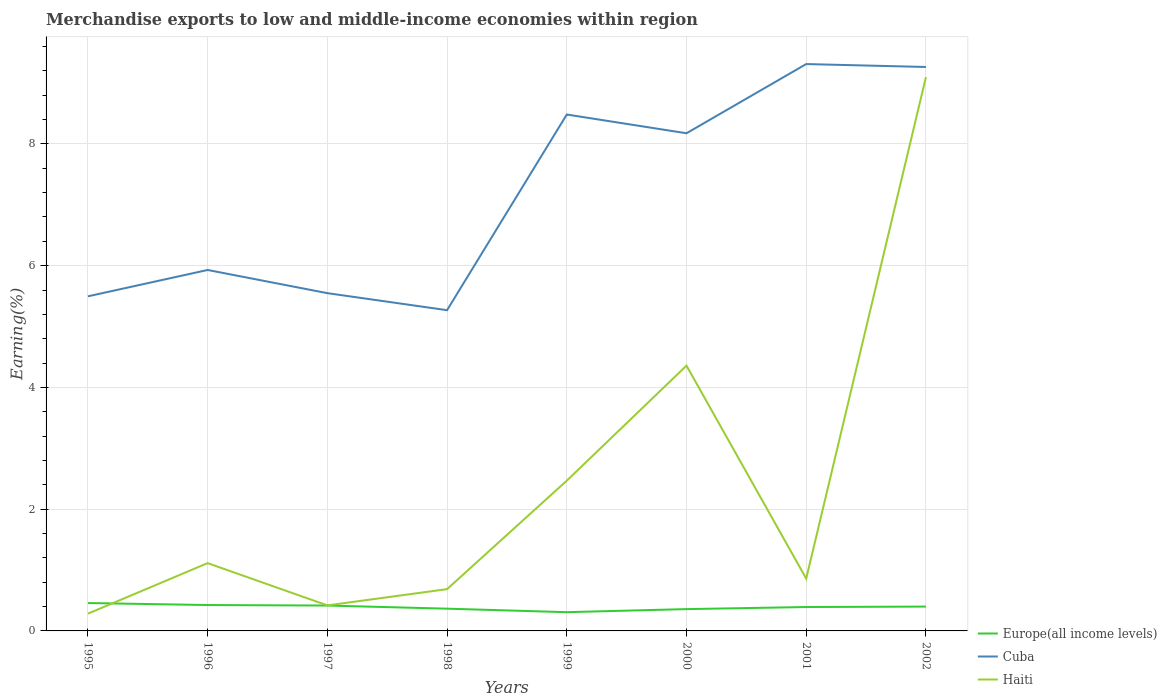How many different coloured lines are there?
Provide a succinct answer. 3. Does the line corresponding to Haiti intersect with the line corresponding to Cuba?
Ensure brevity in your answer.  No. Across all years, what is the maximum percentage of amount earned from merchandise exports in Europe(all income levels)?
Provide a short and direct response. 0.31. In which year was the percentage of amount earned from merchandise exports in Haiti maximum?
Your answer should be very brief. 1995. What is the total percentage of amount earned from merchandise exports in Cuba in the graph?
Provide a short and direct response. -0.43. What is the difference between the highest and the second highest percentage of amount earned from merchandise exports in Cuba?
Keep it short and to the point. 4.04. How many years are there in the graph?
Provide a succinct answer. 8. What is the difference between two consecutive major ticks on the Y-axis?
Make the answer very short. 2. Where does the legend appear in the graph?
Keep it short and to the point. Bottom right. What is the title of the graph?
Offer a terse response. Merchandise exports to low and middle-income economies within region. What is the label or title of the X-axis?
Provide a short and direct response. Years. What is the label or title of the Y-axis?
Give a very brief answer. Earning(%). What is the Earning(%) of Europe(all income levels) in 1995?
Ensure brevity in your answer.  0.46. What is the Earning(%) in Cuba in 1995?
Give a very brief answer. 5.5. What is the Earning(%) in Haiti in 1995?
Your answer should be very brief. 0.28. What is the Earning(%) in Europe(all income levels) in 1996?
Ensure brevity in your answer.  0.43. What is the Earning(%) of Cuba in 1996?
Your answer should be compact. 5.93. What is the Earning(%) in Haiti in 1996?
Your answer should be compact. 1.11. What is the Earning(%) in Europe(all income levels) in 1997?
Give a very brief answer. 0.42. What is the Earning(%) of Cuba in 1997?
Your answer should be very brief. 5.55. What is the Earning(%) of Haiti in 1997?
Give a very brief answer. 0.42. What is the Earning(%) in Europe(all income levels) in 1998?
Your answer should be compact. 0.37. What is the Earning(%) in Cuba in 1998?
Ensure brevity in your answer.  5.27. What is the Earning(%) in Haiti in 1998?
Keep it short and to the point. 0.69. What is the Earning(%) in Europe(all income levels) in 1999?
Ensure brevity in your answer.  0.31. What is the Earning(%) in Cuba in 1999?
Provide a short and direct response. 8.48. What is the Earning(%) in Haiti in 1999?
Provide a succinct answer. 2.47. What is the Earning(%) of Europe(all income levels) in 2000?
Give a very brief answer. 0.36. What is the Earning(%) in Cuba in 2000?
Ensure brevity in your answer.  8.18. What is the Earning(%) of Haiti in 2000?
Your answer should be very brief. 4.36. What is the Earning(%) of Europe(all income levels) in 2001?
Give a very brief answer. 0.39. What is the Earning(%) of Cuba in 2001?
Provide a short and direct response. 9.31. What is the Earning(%) of Haiti in 2001?
Keep it short and to the point. 0.86. What is the Earning(%) in Europe(all income levels) in 2002?
Provide a succinct answer. 0.4. What is the Earning(%) of Cuba in 2002?
Offer a very short reply. 9.26. What is the Earning(%) of Haiti in 2002?
Ensure brevity in your answer.  9.1. Across all years, what is the maximum Earning(%) in Europe(all income levels)?
Give a very brief answer. 0.46. Across all years, what is the maximum Earning(%) of Cuba?
Provide a short and direct response. 9.31. Across all years, what is the maximum Earning(%) of Haiti?
Your response must be concise. 9.1. Across all years, what is the minimum Earning(%) of Europe(all income levels)?
Offer a terse response. 0.31. Across all years, what is the minimum Earning(%) in Cuba?
Give a very brief answer. 5.27. Across all years, what is the minimum Earning(%) in Haiti?
Provide a short and direct response. 0.28. What is the total Earning(%) of Europe(all income levels) in the graph?
Your answer should be very brief. 3.12. What is the total Earning(%) in Cuba in the graph?
Give a very brief answer. 57.48. What is the total Earning(%) of Haiti in the graph?
Ensure brevity in your answer.  19.29. What is the difference between the Earning(%) in Europe(all income levels) in 1995 and that in 1996?
Ensure brevity in your answer.  0.03. What is the difference between the Earning(%) of Cuba in 1995 and that in 1996?
Make the answer very short. -0.43. What is the difference between the Earning(%) of Haiti in 1995 and that in 1996?
Provide a succinct answer. -0.83. What is the difference between the Earning(%) in Europe(all income levels) in 1995 and that in 1997?
Make the answer very short. 0.04. What is the difference between the Earning(%) in Cuba in 1995 and that in 1997?
Provide a short and direct response. -0.05. What is the difference between the Earning(%) in Haiti in 1995 and that in 1997?
Your answer should be compact. -0.14. What is the difference between the Earning(%) of Europe(all income levels) in 1995 and that in 1998?
Your response must be concise. 0.09. What is the difference between the Earning(%) of Cuba in 1995 and that in 1998?
Your answer should be compact. 0.23. What is the difference between the Earning(%) in Haiti in 1995 and that in 1998?
Your answer should be very brief. -0.4. What is the difference between the Earning(%) of Europe(all income levels) in 1995 and that in 1999?
Offer a very short reply. 0.15. What is the difference between the Earning(%) in Cuba in 1995 and that in 1999?
Provide a short and direct response. -2.99. What is the difference between the Earning(%) of Haiti in 1995 and that in 1999?
Your answer should be very brief. -2.18. What is the difference between the Earning(%) of Europe(all income levels) in 1995 and that in 2000?
Your answer should be very brief. 0.1. What is the difference between the Earning(%) of Cuba in 1995 and that in 2000?
Give a very brief answer. -2.68. What is the difference between the Earning(%) in Haiti in 1995 and that in 2000?
Make the answer very short. -4.07. What is the difference between the Earning(%) of Europe(all income levels) in 1995 and that in 2001?
Make the answer very short. 0.07. What is the difference between the Earning(%) in Cuba in 1995 and that in 2001?
Keep it short and to the point. -3.82. What is the difference between the Earning(%) in Haiti in 1995 and that in 2001?
Offer a terse response. -0.58. What is the difference between the Earning(%) of Europe(all income levels) in 1995 and that in 2002?
Ensure brevity in your answer.  0.06. What is the difference between the Earning(%) of Cuba in 1995 and that in 2002?
Your answer should be compact. -3.77. What is the difference between the Earning(%) of Haiti in 1995 and that in 2002?
Give a very brief answer. -8.81. What is the difference between the Earning(%) in Europe(all income levels) in 1996 and that in 1997?
Keep it short and to the point. 0.01. What is the difference between the Earning(%) in Cuba in 1996 and that in 1997?
Make the answer very short. 0.38. What is the difference between the Earning(%) in Haiti in 1996 and that in 1997?
Offer a very short reply. 0.69. What is the difference between the Earning(%) in Europe(all income levels) in 1996 and that in 1998?
Provide a short and direct response. 0.06. What is the difference between the Earning(%) in Cuba in 1996 and that in 1998?
Offer a very short reply. 0.66. What is the difference between the Earning(%) of Haiti in 1996 and that in 1998?
Make the answer very short. 0.43. What is the difference between the Earning(%) in Europe(all income levels) in 1996 and that in 1999?
Ensure brevity in your answer.  0.12. What is the difference between the Earning(%) in Cuba in 1996 and that in 1999?
Provide a succinct answer. -2.55. What is the difference between the Earning(%) of Haiti in 1996 and that in 1999?
Ensure brevity in your answer.  -1.35. What is the difference between the Earning(%) in Europe(all income levels) in 1996 and that in 2000?
Your answer should be very brief. 0.07. What is the difference between the Earning(%) in Cuba in 1996 and that in 2000?
Provide a short and direct response. -2.25. What is the difference between the Earning(%) in Haiti in 1996 and that in 2000?
Offer a very short reply. -3.24. What is the difference between the Earning(%) of Europe(all income levels) in 1996 and that in 2001?
Offer a very short reply. 0.03. What is the difference between the Earning(%) of Cuba in 1996 and that in 2001?
Your answer should be very brief. -3.38. What is the difference between the Earning(%) in Haiti in 1996 and that in 2001?
Give a very brief answer. 0.25. What is the difference between the Earning(%) of Europe(all income levels) in 1996 and that in 2002?
Ensure brevity in your answer.  0.03. What is the difference between the Earning(%) in Cuba in 1996 and that in 2002?
Your answer should be very brief. -3.33. What is the difference between the Earning(%) in Haiti in 1996 and that in 2002?
Give a very brief answer. -7.98. What is the difference between the Earning(%) of Europe(all income levels) in 1997 and that in 1998?
Offer a very short reply. 0.05. What is the difference between the Earning(%) in Cuba in 1997 and that in 1998?
Your response must be concise. 0.28. What is the difference between the Earning(%) of Haiti in 1997 and that in 1998?
Your answer should be compact. -0.27. What is the difference between the Earning(%) in Europe(all income levels) in 1997 and that in 1999?
Keep it short and to the point. 0.11. What is the difference between the Earning(%) in Cuba in 1997 and that in 1999?
Keep it short and to the point. -2.93. What is the difference between the Earning(%) in Haiti in 1997 and that in 1999?
Offer a terse response. -2.05. What is the difference between the Earning(%) of Europe(all income levels) in 1997 and that in 2000?
Make the answer very short. 0.06. What is the difference between the Earning(%) of Cuba in 1997 and that in 2000?
Keep it short and to the point. -2.63. What is the difference between the Earning(%) of Haiti in 1997 and that in 2000?
Ensure brevity in your answer.  -3.94. What is the difference between the Earning(%) of Europe(all income levels) in 1997 and that in 2001?
Your response must be concise. 0.02. What is the difference between the Earning(%) in Cuba in 1997 and that in 2001?
Keep it short and to the point. -3.76. What is the difference between the Earning(%) in Haiti in 1997 and that in 2001?
Ensure brevity in your answer.  -0.44. What is the difference between the Earning(%) of Europe(all income levels) in 1997 and that in 2002?
Offer a very short reply. 0.02. What is the difference between the Earning(%) in Cuba in 1997 and that in 2002?
Keep it short and to the point. -3.72. What is the difference between the Earning(%) of Haiti in 1997 and that in 2002?
Your answer should be compact. -8.68. What is the difference between the Earning(%) of Europe(all income levels) in 1998 and that in 1999?
Offer a terse response. 0.06. What is the difference between the Earning(%) in Cuba in 1998 and that in 1999?
Ensure brevity in your answer.  -3.21. What is the difference between the Earning(%) of Haiti in 1998 and that in 1999?
Ensure brevity in your answer.  -1.78. What is the difference between the Earning(%) in Europe(all income levels) in 1998 and that in 2000?
Give a very brief answer. 0.01. What is the difference between the Earning(%) in Cuba in 1998 and that in 2000?
Provide a succinct answer. -2.91. What is the difference between the Earning(%) in Haiti in 1998 and that in 2000?
Offer a very short reply. -3.67. What is the difference between the Earning(%) of Europe(all income levels) in 1998 and that in 2001?
Offer a terse response. -0.03. What is the difference between the Earning(%) of Cuba in 1998 and that in 2001?
Keep it short and to the point. -4.04. What is the difference between the Earning(%) in Haiti in 1998 and that in 2001?
Give a very brief answer. -0.17. What is the difference between the Earning(%) of Europe(all income levels) in 1998 and that in 2002?
Offer a terse response. -0.03. What is the difference between the Earning(%) of Cuba in 1998 and that in 2002?
Your answer should be very brief. -4. What is the difference between the Earning(%) in Haiti in 1998 and that in 2002?
Your response must be concise. -8.41. What is the difference between the Earning(%) in Europe(all income levels) in 1999 and that in 2000?
Keep it short and to the point. -0.05. What is the difference between the Earning(%) of Cuba in 1999 and that in 2000?
Offer a very short reply. 0.31. What is the difference between the Earning(%) in Haiti in 1999 and that in 2000?
Ensure brevity in your answer.  -1.89. What is the difference between the Earning(%) of Europe(all income levels) in 1999 and that in 2001?
Provide a succinct answer. -0.08. What is the difference between the Earning(%) in Cuba in 1999 and that in 2001?
Your answer should be compact. -0.83. What is the difference between the Earning(%) of Haiti in 1999 and that in 2001?
Offer a terse response. 1.61. What is the difference between the Earning(%) in Europe(all income levels) in 1999 and that in 2002?
Keep it short and to the point. -0.09. What is the difference between the Earning(%) in Cuba in 1999 and that in 2002?
Ensure brevity in your answer.  -0.78. What is the difference between the Earning(%) in Haiti in 1999 and that in 2002?
Keep it short and to the point. -6.63. What is the difference between the Earning(%) of Europe(all income levels) in 2000 and that in 2001?
Provide a short and direct response. -0.03. What is the difference between the Earning(%) of Cuba in 2000 and that in 2001?
Your answer should be very brief. -1.14. What is the difference between the Earning(%) of Haiti in 2000 and that in 2001?
Your answer should be compact. 3.5. What is the difference between the Earning(%) in Europe(all income levels) in 2000 and that in 2002?
Your answer should be compact. -0.04. What is the difference between the Earning(%) of Cuba in 2000 and that in 2002?
Provide a succinct answer. -1.09. What is the difference between the Earning(%) of Haiti in 2000 and that in 2002?
Offer a terse response. -4.74. What is the difference between the Earning(%) in Europe(all income levels) in 2001 and that in 2002?
Provide a short and direct response. -0.01. What is the difference between the Earning(%) of Cuba in 2001 and that in 2002?
Your answer should be very brief. 0.05. What is the difference between the Earning(%) of Haiti in 2001 and that in 2002?
Keep it short and to the point. -8.24. What is the difference between the Earning(%) of Europe(all income levels) in 1995 and the Earning(%) of Cuba in 1996?
Keep it short and to the point. -5.47. What is the difference between the Earning(%) of Europe(all income levels) in 1995 and the Earning(%) of Haiti in 1996?
Give a very brief answer. -0.66. What is the difference between the Earning(%) in Cuba in 1995 and the Earning(%) in Haiti in 1996?
Your answer should be compact. 4.38. What is the difference between the Earning(%) in Europe(all income levels) in 1995 and the Earning(%) in Cuba in 1997?
Your response must be concise. -5.09. What is the difference between the Earning(%) of Europe(all income levels) in 1995 and the Earning(%) of Haiti in 1997?
Offer a very short reply. 0.04. What is the difference between the Earning(%) of Cuba in 1995 and the Earning(%) of Haiti in 1997?
Make the answer very short. 5.08. What is the difference between the Earning(%) in Europe(all income levels) in 1995 and the Earning(%) in Cuba in 1998?
Give a very brief answer. -4.81. What is the difference between the Earning(%) in Europe(all income levels) in 1995 and the Earning(%) in Haiti in 1998?
Provide a succinct answer. -0.23. What is the difference between the Earning(%) of Cuba in 1995 and the Earning(%) of Haiti in 1998?
Keep it short and to the point. 4.81. What is the difference between the Earning(%) in Europe(all income levels) in 1995 and the Earning(%) in Cuba in 1999?
Keep it short and to the point. -8.03. What is the difference between the Earning(%) of Europe(all income levels) in 1995 and the Earning(%) of Haiti in 1999?
Provide a short and direct response. -2.01. What is the difference between the Earning(%) of Cuba in 1995 and the Earning(%) of Haiti in 1999?
Make the answer very short. 3.03. What is the difference between the Earning(%) in Europe(all income levels) in 1995 and the Earning(%) in Cuba in 2000?
Your answer should be very brief. -7.72. What is the difference between the Earning(%) of Europe(all income levels) in 1995 and the Earning(%) of Haiti in 2000?
Your response must be concise. -3.9. What is the difference between the Earning(%) in Cuba in 1995 and the Earning(%) in Haiti in 2000?
Provide a succinct answer. 1.14. What is the difference between the Earning(%) of Europe(all income levels) in 1995 and the Earning(%) of Cuba in 2001?
Offer a very short reply. -8.85. What is the difference between the Earning(%) of Europe(all income levels) in 1995 and the Earning(%) of Haiti in 2001?
Provide a succinct answer. -0.4. What is the difference between the Earning(%) in Cuba in 1995 and the Earning(%) in Haiti in 2001?
Make the answer very short. 4.64. What is the difference between the Earning(%) of Europe(all income levels) in 1995 and the Earning(%) of Cuba in 2002?
Ensure brevity in your answer.  -8.81. What is the difference between the Earning(%) of Europe(all income levels) in 1995 and the Earning(%) of Haiti in 2002?
Provide a succinct answer. -8.64. What is the difference between the Earning(%) in Cuba in 1995 and the Earning(%) in Haiti in 2002?
Ensure brevity in your answer.  -3.6. What is the difference between the Earning(%) of Europe(all income levels) in 1996 and the Earning(%) of Cuba in 1997?
Provide a short and direct response. -5.12. What is the difference between the Earning(%) of Europe(all income levels) in 1996 and the Earning(%) of Haiti in 1997?
Your answer should be compact. 0.01. What is the difference between the Earning(%) of Cuba in 1996 and the Earning(%) of Haiti in 1997?
Provide a succinct answer. 5.51. What is the difference between the Earning(%) of Europe(all income levels) in 1996 and the Earning(%) of Cuba in 1998?
Ensure brevity in your answer.  -4.84. What is the difference between the Earning(%) of Europe(all income levels) in 1996 and the Earning(%) of Haiti in 1998?
Offer a very short reply. -0.26. What is the difference between the Earning(%) in Cuba in 1996 and the Earning(%) in Haiti in 1998?
Your answer should be compact. 5.24. What is the difference between the Earning(%) in Europe(all income levels) in 1996 and the Earning(%) in Cuba in 1999?
Offer a terse response. -8.06. What is the difference between the Earning(%) of Europe(all income levels) in 1996 and the Earning(%) of Haiti in 1999?
Offer a terse response. -2.04. What is the difference between the Earning(%) in Cuba in 1996 and the Earning(%) in Haiti in 1999?
Provide a succinct answer. 3.46. What is the difference between the Earning(%) in Europe(all income levels) in 1996 and the Earning(%) in Cuba in 2000?
Offer a terse response. -7.75. What is the difference between the Earning(%) in Europe(all income levels) in 1996 and the Earning(%) in Haiti in 2000?
Your answer should be compact. -3.93. What is the difference between the Earning(%) of Cuba in 1996 and the Earning(%) of Haiti in 2000?
Provide a short and direct response. 1.57. What is the difference between the Earning(%) in Europe(all income levels) in 1996 and the Earning(%) in Cuba in 2001?
Make the answer very short. -8.89. What is the difference between the Earning(%) in Europe(all income levels) in 1996 and the Earning(%) in Haiti in 2001?
Keep it short and to the point. -0.43. What is the difference between the Earning(%) of Cuba in 1996 and the Earning(%) of Haiti in 2001?
Offer a terse response. 5.07. What is the difference between the Earning(%) in Europe(all income levels) in 1996 and the Earning(%) in Cuba in 2002?
Offer a terse response. -8.84. What is the difference between the Earning(%) in Europe(all income levels) in 1996 and the Earning(%) in Haiti in 2002?
Provide a short and direct response. -8.67. What is the difference between the Earning(%) in Cuba in 1996 and the Earning(%) in Haiti in 2002?
Provide a succinct answer. -3.17. What is the difference between the Earning(%) of Europe(all income levels) in 1997 and the Earning(%) of Cuba in 1998?
Ensure brevity in your answer.  -4.85. What is the difference between the Earning(%) of Europe(all income levels) in 1997 and the Earning(%) of Haiti in 1998?
Make the answer very short. -0.27. What is the difference between the Earning(%) of Cuba in 1997 and the Earning(%) of Haiti in 1998?
Your response must be concise. 4.86. What is the difference between the Earning(%) of Europe(all income levels) in 1997 and the Earning(%) of Cuba in 1999?
Provide a succinct answer. -8.07. What is the difference between the Earning(%) in Europe(all income levels) in 1997 and the Earning(%) in Haiti in 1999?
Give a very brief answer. -2.05. What is the difference between the Earning(%) of Cuba in 1997 and the Earning(%) of Haiti in 1999?
Your answer should be compact. 3.08. What is the difference between the Earning(%) of Europe(all income levels) in 1997 and the Earning(%) of Cuba in 2000?
Your answer should be compact. -7.76. What is the difference between the Earning(%) of Europe(all income levels) in 1997 and the Earning(%) of Haiti in 2000?
Ensure brevity in your answer.  -3.94. What is the difference between the Earning(%) in Cuba in 1997 and the Earning(%) in Haiti in 2000?
Provide a succinct answer. 1.19. What is the difference between the Earning(%) of Europe(all income levels) in 1997 and the Earning(%) of Cuba in 2001?
Keep it short and to the point. -8.9. What is the difference between the Earning(%) in Europe(all income levels) in 1997 and the Earning(%) in Haiti in 2001?
Provide a succinct answer. -0.44. What is the difference between the Earning(%) of Cuba in 1997 and the Earning(%) of Haiti in 2001?
Ensure brevity in your answer.  4.69. What is the difference between the Earning(%) of Europe(all income levels) in 1997 and the Earning(%) of Cuba in 2002?
Offer a very short reply. -8.85. What is the difference between the Earning(%) in Europe(all income levels) in 1997 and the Earning(%) in Haiti in 2002?
Keep it short and to the point. -8.68. What is the difference between the Earning(%) in Cuba in 1997 and the Earning(%) in Haiti in 2002?
Keep it short and to the point. -3.55. What is the difference between the Earning(%) of Europe(all income levels) in 1998 and the Earning(%) of Cuba in 1999?
Keep it short and to the point. -8.12. What is the difference between the Earning(%) of Europe(all income levels) in 1998 and the Earning(%) of Haiti in 1999?
Your answer should be very brief. -2.1. What is the difference between the Earning(%) in Cuba in 1998 and the Earning(%) in Haiti in 1999?
Your response must be concise. 2.8. What is the difference between the Earning(%) in Europe(all income levels) in 1998 and the Earning(%) in Cuba in 2000?
Provide a short and direct response. -7.81. What is the difference between the Earning(%) in Europe(all income levels) in 1998 and the Earning(%) in Haiti in 2000?
Make the answer very short. -3.99. What is the difference between the Earning(%) in Cuba in 1998 and the Earning(%) in Haiti in 2000?
Your answer should be very brief. 0.91. What is the difference between the Earning(%) of Europe(all income levels) in 1998 and the Earning(%) of Cuba in 2001?
Provide a succinct answer. -8.95. What is the difference between the Earning(%) of Europe(all income levels) in 1998 and the Earning(%) of Haiti in 2001?
Your answer should be very brief. -0.49. What is the difference between the Earning(%) of Cuba in 1998 and the Earning(%) of Haiti in 2001?
Offer a terse response. 4.41. What is the difference between the Earning(%) in Europe(all income levels) in 1998 and the Earning(%) in Cuba in 2002?
Keep it short and to the point. -8.9. What is the difference between the Earning(%) in Europe(all income levels) in 1998 and the Earning(%) in Haiti in 2002?
Offer a terse response. -8.73. What is the difference between the Earning(%) of Cuba in 1998 and the Earning(%) of Haiti in 2002?
Make the answer very short. -3.83. What is the difference between the Earning(%) of Europe(all income levels) in 1999 and the Earning(%) of Cuba in 2000?
Offer a terse response. -7.87. What is the difference between the Earning(%) in Europe(all income levels) in 1999 and the Earning(%) in Haiti in 2000?
Give a very brief answer. -4.05. What is the difference between the Earning(%) in Cuba in 1999 and the Earning(%) in Haiti in 2000?
Keep it short and to the point. 4.13. What is the difference between the Earning(%) in Europe(all income levels) in 1999 and the Earning(%) in Cuba in 2001?
Offer a very short reply. -9. What is the difference between the Earning(%) in Europe(all income levels) in 1999 and the Earning(%) in Haiti in 2001?
Give a very brief answer. -0.55. What is the difference between the Earning(%) of Cuba in 1999 and the Earning(%) of Haiti in 2001?
Offer a terse response. 7.62. What is the difference between the Earning(%) of Europe(all income levels) in 1999 and the Earning(%) of Cuba in 2002?
Offer a terse response. -8.96. What is the difference between the Earning(%) of Europe(all income levels) in 1999 and the Earning(%) of Haiti in 2002?
Provide a succinct answer. -8.79. What is the difference between the Earning(%) of Cuba in 1999 and the Earning(%) of Haiti in 2002?
Make the answer very short. -0.61. What is the difference between the Earning(%) of Europe(all income levels) in 2000 and the Earning(%) of Cuba in 2001?
Keep it short and to the point. -8.95. What is the difference between the Earning(%) in Europe(all income levels) in 2000 and the Earning(%) in Haiti in 2001?
Your answer should be compact. -0.5. What is the difference between the Earning(%) in Cuba in 2000 and the Earning(%) in Haiti in 2001?
Your answer should be compact. 7.32. What is the difference between the Earning(%) in Europe(all income levels) in 2000 and the Earning(%) in Cuba in 2002?
Your answer should be very brief. -8.91. What is the difference between the Earning(%) in Europe(all income levels) in 2000 and the Earning(%) in Haiti in 2002?
Your response must be concise. -8.74. What is the difference between the Earning(%) of Cuba in 2000 and the Earning(%) of Haiti in 2002?
Offer a very short reply. -0.92. What is the difference between the Earning(%) in Europe(all income levels) in 2001 and the Earning(%) in Cuba in 2002?
Provide a short and direct response. -8.87. What is the difference between the Earning(%) of Europe(all income levels) in 2001 and the Earning(%) of Haiti in 2002?
Your answer should be very brief. -8.7. What is the difference between the Earning(%) in Cuba in 2001 and the Earning(%) in Haiti in 2002?
Your answer should be compact. 0.21. What is the average Earning(%) in Europe(all income levels) per year?
Keep it short and to the point. 0.39. What is the average Earning(%) in Cuba per year?
Your answer should be very brief. 7.18. What is the average Earning(%) of Haiti per year?
Ensure brevity in your answer.  2.41. In the year 1995, what is the difference between the Earning(%) in Europe(all income levels) and Earning(%) in Cuba?
Provide a short and direct response. -5.04. In the year 1995, what is the difference between the Earning(%) of Europe(all income levels) and Earning(%) of Haiti?
Your response must be concise. 0.17. In the year 1995, what is the difference between the Earning(%) of Cuba and Earning(%) of Haiti?
Your response must be concise. 5.21. In the year 1996, what is the difference between the Earning(%) in Europe(all income levels) and Earning(%) in Cuba?
Make the answer very short. -5.5. In the year 1996, what is the difference between the Earning(%) of Europe(all income levels) and Earning(%) of Haiti?
Keep it short and to the point. -0.69. In the year 1996, what is the difference between the Earning(%) of Cuba and Earning(%) of Haiti?
Offer a terse response. 4.82. In the year 1997, what is the difference between the Earning(%) of Europe(all income levels) and Earning(%) of Cuba?
Ensure brevity in your answer.  -5.13. In the year 1997, what is the difference between the Earning(%) of Europe(all income levels) and Earning(%) of Haiti?
Provide a succinct answer. -0. In the year 1997, what is the difference between the Earning(%) of Cuba and Earning(%) of Haiti?
Make the answer very short. 5.13. In the year 1998, what is the difference between the Earning(%) in Europe(all income levels) and Earning(%) in Cuba?
Offer a very short reply. -4.9. In the year 1998, what is the difference between the Earning(%) of Europe(all income levels) and Earning(%) of Haiti?
Your response must be concise. -0.32. In the year 1998, what is the difference between the Earning(%) of Cuba and Earning(%) of Haiti?
Your response must be concise. 4.58. In the year 1999, what is the difference between the Earning(%) of Europe(all income levels) and Earning(%) of Cuba?
Offer a very short reply. -8.18. In the year 1999, what is the difference between the Earning(%) of Europe(all income levels) and Earning(%) of Haiti?
Ensure brevity in your answer.  -2.16. In the year 1999, what is the difference between the Earning(%) in Cuba and Earning(%) in Haiti?
Your answer should be very brief. 6.01. In the year 2000, what is the difference between the Earning(%) in Europe(all income levels) and Earning(%) in Cuba?
Your answer should be compact. -7.82. In the year 2000, what is the difference between the Earning(%) of Europe(all income levels) and Earning(%) of Haiti?
Ensure brevity in your answer.  -4. In the year 2000, what is the difference between the Earning(%) in Cuba and Earning(%) in Haiti?
Keep it short and to the point. 3.82. In the year 2001, what is the difference between the Earning(%) of Europe(all income levels) and Earning(%) of Cuba?
Keep it short and to the point. -8.92. In the year 2001, what is the difference between the Earning(%) of Europe(all income levels) and Earning(%) of Haiti?
Your response must be concise. -0.47. In the year 2001, what is the difference between the Earning(%) in Cuba and Earning(%) in Haiti?
Your answer should be very brief. 8.45. In the year 2002, what is the difference between the Earning(%) of Europe(all income levels) and Earning(%) of Cuba?
Provide a succinct answer. -8.86. In the year 2002, what is the difference between the Earning(%) of Europe(all income levels) and Earning(%) of Haiti?
Keep it short and to the point. -8.7. In the year 2002, what is the difference between the Earning(%) in Cuba and Earning(%) in Haiti?
Provide a succinct answer. 0.17. What is the ratio of the Earning(%) in Cuba in 1995 to that in 1996?
Offer a very short reply. 0.93. What is the ratio of the Earning(%) of Haiti in 1995 to that in 1996?
Offer a terse response. 0.25. What is the ratio of the Earning(%) of Europe(all income levels) in 1995 to that in 1997?
Provide a succinct answer. 1.1. What is the ratio of the Earning(%) of Cuba in 1995 to that in 1997?
Give a very brief answer. 0.99. What is the ratio of the Earning(%) in Haiti in 1995 to that in 1997?
Make the answer very short. 0.68. What is the ratio of the Earning(%) in Europe(all income levels) in 1995 to that in 1998?
Provide a succinct answer. 1.25. What is the ratio of the Earning(%) of Cuba in 1995 to that in 1998?
Provide a succinct answer. 1.04. What is the ratio of the Earning(%) of Haiti in 1995 to that in 1998?
Your response must be concise. 0.41. What is the ratio of the Earning(%) in Europe(all income levels) in 1995 to that in 1999?
Offer a very short reply. 1.49. What is the ratio of the Earning(%) in Cuba in 1995 to that in 1999?
Your answer should be very brief. 0.65. What is the ratio of the Earning(%) of Haiti in 1995 to that in 1999?
Ensure brevity in your answer.  0.11. What is the ratio of the Earning(%) of Europe(all income levels) in 1995 to that in 2000?
Provide a succinct answer. 1.28. What is the ratio of the Earning(%) of Cuba in 1995 to that in 2000?
Give a very brief answer. 0.67. What is the ratio of the Earning(%) in Haiti in 1995 to that in 2000?
Ensure brevity in your answer.  0.07. What is the ratio of the Earning(%) in Europe(all income levels) in 1995 to that in 2001?
Offer a very short reply. 1.17. What is the ratio of the Earning(%) of Cuba in 1995 to that in 2001?
Your answer should be compact. 0.59. What is the ratio of the Earning(%) in Haiti in 1995 to that in 2001?
Your answer should be compact. 0.33. What is the ratio of the Earning(%) of Europe(all income levels) in 1995 to that in 2002?
Ensure brevity in your answer.  1.15. What is the ratio of the Earning(%) in Cuba in 1995 to that in 2002?
Give a very brief answer. 0.59. What is the ratio of the Earning(%) of Haiti in 1995 to that in 2002?
Your answer should be very brief. 0.03. What is the ratio of the Earning(%) in Europe(all income levels) in 1996 to that in 1997?
Offer a very short reply. 1.02. What is the ratio of the Earning(%) in Cuba in 1996 to that in 1997?
Make the answer very short. 1.07. What is the ratio of the Earning(%) in Haiti in 1996 to that in 1997?
Make the answer very short. 2.65. What is the ratio of the Earning(%) in Europe(all income levels) in 1996 to that in 1998?
Your response must be concise. 1.16. What is the ratio of the Earning(%) in Cuba in 1996 to that in 1998?
Provide a succinct answer. 1.13. What is the ratio of the Earning(%) of Haiti in 1996 to that in 1998?
Provide a short and direct response. 1.62. What is the ratio of the Earning(%) of Europe(all income levels) in 1996 to that in 1999?
Your answer should be very brief. 1.38. What is the ratio of the Earning(%) in Cuba in 1996 to that in 1999?
Your answer should be very brief. 0.7. What is the ratio of the Earning(%) in Haiti in 1996 to that in 1999?
Provide a short and direct response. 0.45. What is the ratio of the Earning(%) of Europe(all income levels) in 1996 to that in 2000?
Make the answer very short. 1.19. What is the ratio of the Earning(%) of Cuba in 1996 to that in 2000?
Your response must be concise. 0.73. What is the ratio of the Earning(%) in Haiti in 1996 to that in 2000?
Your answer should be very brief. 0.26. What is the ratio of the Earning(%) in Europe(all income levels) in 1996 to that in 2001?
Make the answer very short. 1.08. What is the ratio of the Earning(%) in Cuba in 1996 to that in 2001?
Offer a terse response. 0.64. What is the ratio of the Earning(%) in Haiti in 1996 to that in 2001?
Provide a short and direct response. 1.3. What is the ratio of the Earning(%) in Europe(all income levels) in 1996 to that in 2002?
Your response must be concise. 1.06. What is the ratio of the Earning(%) in Cuba in 1996 to that in 2002?
Your response must be concise. 0.64. What is the ratio of the Earning(%) in Haiti in 1996 to that in 2002?
Offer a terse response. 0.12. What is the ratio of the Earning(%) in Europe(all income levels) in 1997 to that in 1998?
Offer a terse response. 1.14. What is the ratio of the Earning(%) in Cuba in 1997 to that in 1998?
Offer a very short reply. 1.05. What is the ratio of the Earning(%) in Haiti in 1997 to that in 1998?
Give a very brief answer. 0.61. What is the ratio of the Earning(%) of Europe(all income levels) in 1997 to that in 1999?
Give a very brief answer. 1.35. What is the ratio of the Earning(%) of Cuba in 1997 to that in 1999?
Your response must be concise. 0.65. What is the ratio of the Earning(%) of Haiti in 1997 to that in 1999?
Your response must be concise. 0.17. What is the ratio of the Earning(%) of Europe(all income levels) in 1997 to that in 2000?
Keep it short and to the point. 1.16. What is the ratio of the Earning(%) of Cuba in 1997 to that in 2000?
Keep it short and to the point. 0.68. What is the ratio of the Earning(%) in Haiti in 1997 to that in 2000?
Make the answer very short. 0.1. What is the ratio of the Earning(%) of Europe(all income levels) in 1997 to that in 2001?
Your answer should be very brief. 1.06. What is the ratio of the Earning(%) in Cuba in 1997 to that in 2001?
Keep it short and to the point. 0.6. What is the ratio of the Earning(%) of Haiti in 1997 to that in 2001?
Your answer should be very brief. 0.49. What is the ratio of the Earning(%) of Europe(all income levels) in 1997 to that in 2002?
Keep it short and to the point. 1.04. What is the ratio of the Earning(%) in Cuba in 1997 to that in 2002?
Offer a terse response. 0.6. What is the ratio of the Earning(%) in Haiti in 1997 to that in 2002?
Your answer should be very brief. 0.05. What is the ratio of the Earning(%) in Europe(all income levels) in 1998 to that in 1999?
Ensure brevity in your answer.  1.19. What is the ratio of the Earning(%) of Cuba in 1998 to that in 1999?
Make the answer very short. 0.62. What is the ratio of the Earning(%) in Haiti in 1998 to that in 1999?
Offer a terse response. 0.28. What is the ratio of the Earning(%) in Europe(all income levels) in 1998 to that in 2000?
Offer a very short reply. 1.02. What is the ratio of the Earning(%) of Cuba in 1998 to that in 2000?
Offer a terse response. 0.64. What is the ratio of the Earning(%) of Haiti in 1998 to that in 2000?
Provide a short and direct response. 0.16. What is the ratio of the Earning(%) of Europe(all income levels) in 1998 to that in 2001?
Provide a succinct answer. 0.93. What is the ratio of the Earning(%) in Cuba in 1998 to that in 2001?
Make the answer very short. 0.57. What is the ratio of the Earning(%) of Haiti in 1998 to that in 2001?
Give a very brief answer. 0.8. What is the ratio of the Earning(%) of Europe(all income levels) in 1998 to that in 2002?
Offer a terse response. 0.91. What is the ratio of the Earning(%) in Cuba in 1998 to that in 2002?
Ensure brevity in your answer.  0.57. What is the ratio of the Earning(%) of Haiti in 1998 to that in 2002?
Keep it short and to the point. 0.08. What is the ratio of the Earning(%) in Europe(all income levels) in 1999 to that in 2000?
Your answer should be very brief. 0.86. What is the ratio of the Earning(%) in Cuba in 1999 to that in 2000?
Make the answer very short. 1.04. What is the ratio of the Earning(%) in Haiti in 1999 to that in 2000?
Provide a succinct answer. 0.57. What is the ratio of the Earning(%) in Europe(all income levels) in 1999 to that in 2001?
Make the answer very short. 0.79. What is the ratio of the Earning(%) of Cuba in 1999 to that in 2001?
Your response must be concise. 0.91. What is the ratio of the Earning(%) of Haiti in 1999 to that in 2001?
Provide a succinct answer. 2.87. What is the ratio of the Earning(%) of Europe(all income levels) in 1999 to that in 2002?
Your answer should be compact. 0.77. What is the ratio of the Earning(%) of Cuba in 1999 to that in 2002?
Give a very brief answer. 0.92. What is the ratio of the Earning(%) in Haiti in 1999 to that in 2002?
Give a very brief answer. 0.27. What is the ratio of the Earning(%) in Europe(all income levels) in 2000 to that in 2001?
Keep it short and to the point. 0.91. What is the ratio of the Earning(%) in Cuba in 2000 to that in 2001?
Keep it short and to the point. 0.88. What is the ratio of the Earning(%) in Haiti in 2000 to that in 2001?
Offer a very short reply. 5.07. What is the ratio of the Earning(%) of Europe(all income levels) in 2000 to that in 2002?
Offer a terse response. 0.9. What is the ratio of the Earning(%) of Cuba in 2000 to that in 2002?
Offer a very short reply. 0.88. What is the ratio of the Earning(%) in Haiti in 2000 to that in 2002?
Give a very brief answer. 0.48. What is the ratio of the Earning(%) of Europe(all income levels) in 2001 to that in 2002?
Your answer should be compact. 0.98. What is the ratio of the Earning(%) of Cuba in 2001 to that in 2002?
Make the answer very short. 1.01. What is the ratio of the Earning(%) in Haiti in 2001 to that in 2002?
Offer a very short reply. 0.09. What is the difference between the highest and the second highest Earning(%) of Europe(all income levels)?
Give a very brief answer. 0.03. What is the difference between the highest and the second highest Earning(%) in Cuba?
Your response must be concise. 0.05. What is the difference between the highest and the second highest Earning(%) of Haiti?
Provide a succinct answer. 4.74. What is the difference between the highest and the lowest Earning(%) of Cuba?
Your response must be concise. 4.04. What is the difference between the highest and the lowest Earning(%) of Haiti?
Your answer should be very brief. 8.81. 